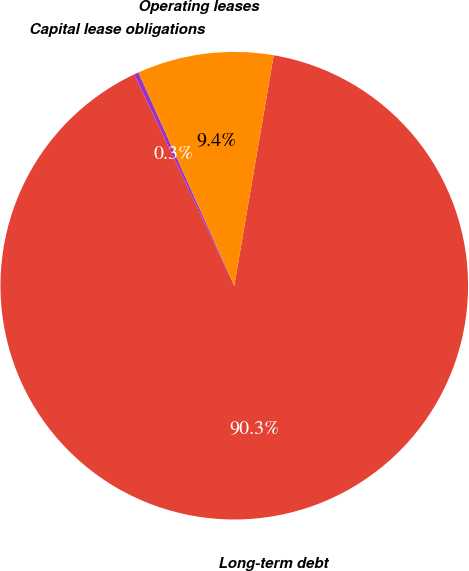Convert chart to OTSL. <chart><loc_0><loc_0><loc_500><loc_500><pie_chart><fcel>Long-term debt<fcel>Capital lease obligations<fcel>Operating leases<nl><fcel>90.26%<fcel>0.32%<fcel>9.42%<nl></chart> 